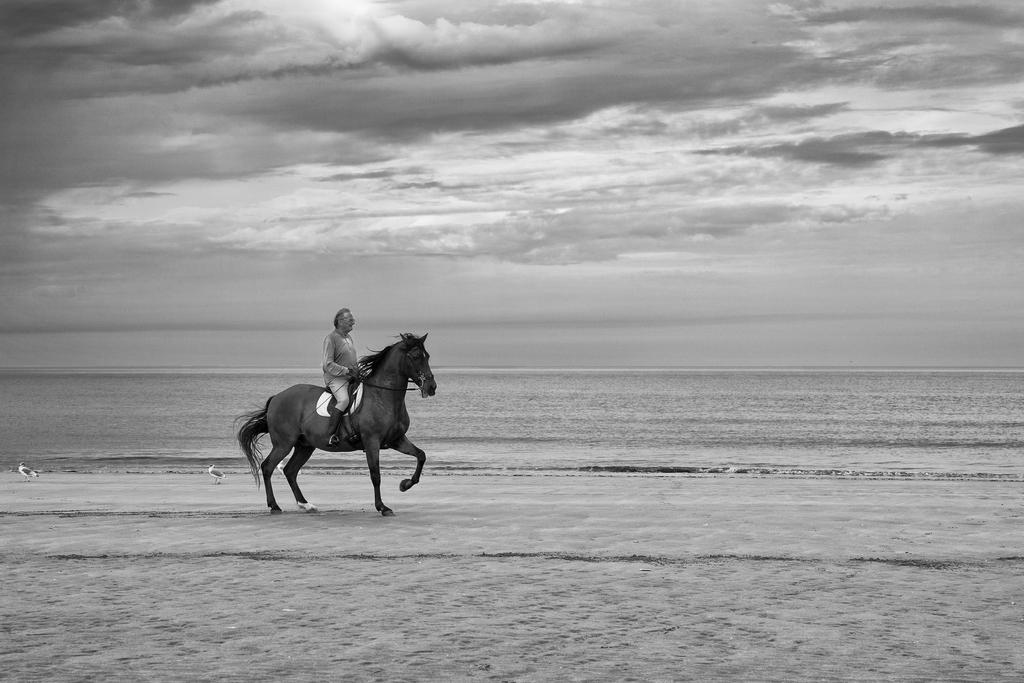What is the main subject of the image? There is a man in the image. What is the man doing in the image? The man is riding a horse. What can be seen in the background of the image? There is water in the image, and the area is surrounded by water. What is the condition of the ground in the image? The floor in the image is muddy. What type of song can be heard playing in the background of the image? There is no indication of any music or song in the image, so it cannot be determined from the picture. 